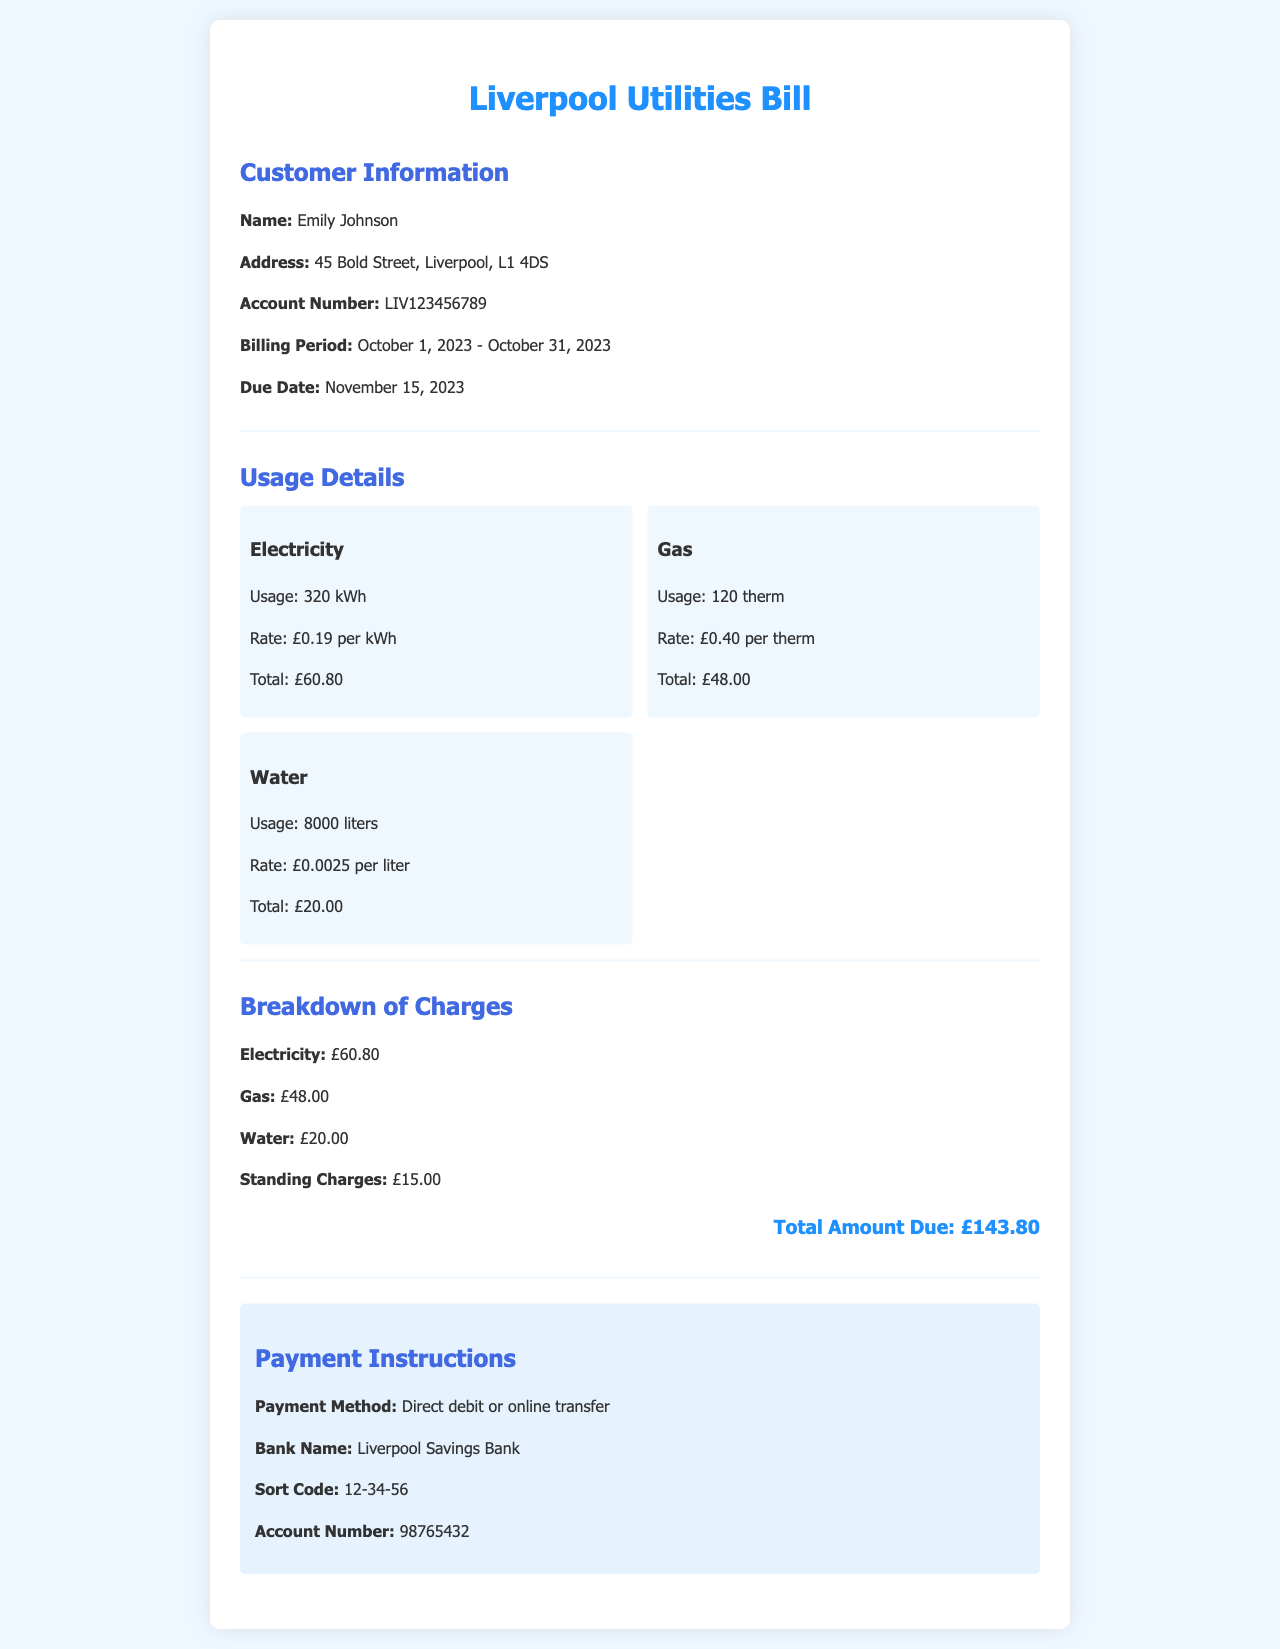what is the name of the customer? The name of the customer is listed in the document under Customer Information, specifically stated as Emily Johnson.
Answer: Emily Johnson what is the billing period? The billing period is defined in the document, indicating the time frame for the bill, which is from October 1, 2023, to October 31, 2023.
Answer: October 1, 2023 - October 31, 2023 how much is the total charge for electricity? The total charge for electricity is provided under the Usage Details and is explicitly stated in the Breakdown of Charges as £60.80.
Answer: £60.80 what is the rate for gas usage? The rate for gas usage is mentioned under Usage Details, indicating the cost per therm used. The document states this as £0.40 per therm.
Answer: £0.40 per therm what is the total amount due? The total amount due is summarized at the end of the Breakdown of Charges section, which totals all charges including standing charges.
Answer: £143.80 how many liters of water were used? The amount of water used is documented in the Usage Details section, specifically listing the usage in liters. It is indicated as 8000 liters.
Answer: 8000 liters what payment methods are available? The document specifies the payment methods under Payment Instructions, which includes options that customers can choose for making payments.
Answer: Direct debit or online transfer what is the due date for this bill? The due date for the bill is provided in the Customer Information section, indicating when payment should be completed. The document states this as November 15, 2023.
Answer: November 15, 2023 